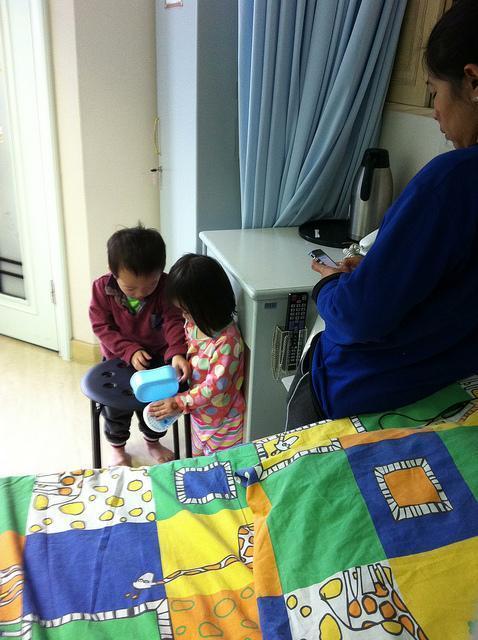How many people can be seen?
Give a very brief answer. 3. How many people are in the photo?
Give a very brief answer. 3. 